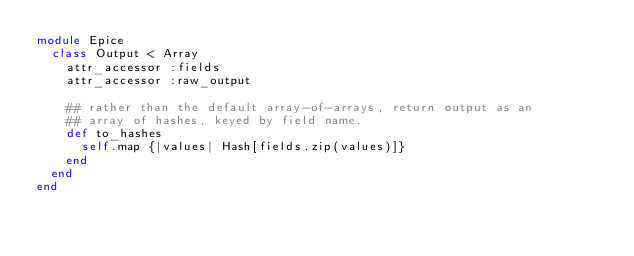<code> <loc_0><loc_0><loc_500><loc_500><_Ruby_>module Epice
  class Output < Array
    attr_accessor :fields
    attr_accessor :raw_output

    ## rather than the default array-of-arrays, return output as an
    ## array of hashes, keyed by field name.
    def to_hashes
      self.map {|values| Hash[fields.zip(values)]}
    end
  end
end
</code> 